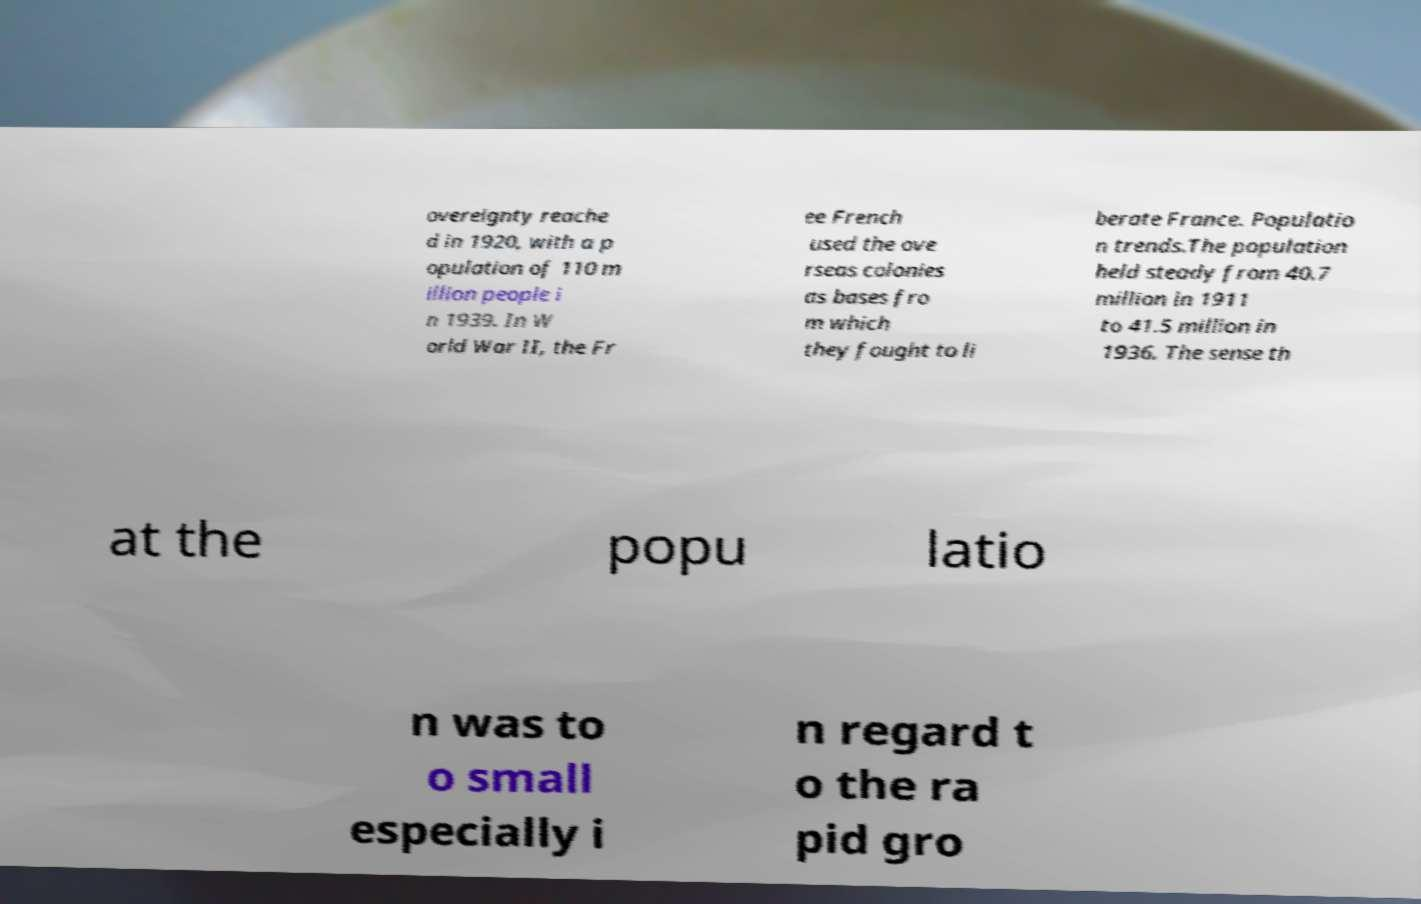Can you read and provide the text displayed in the image?This photo seems to have some interesting text. Can you extract and type it out for me? overeignty reache d in 1920, with a p opulation of 110 m illion people i n 1939. In W orld War II, the Fr ee French used the ove rseas colonies as bases fro m which they fought to li berate France. Populatio n trends.The population held steady from 40.7 million in 1911 to 41.5 million in 1936. The sense th at the popu latio n was to o small especially i n regard t o the ra pid gro 